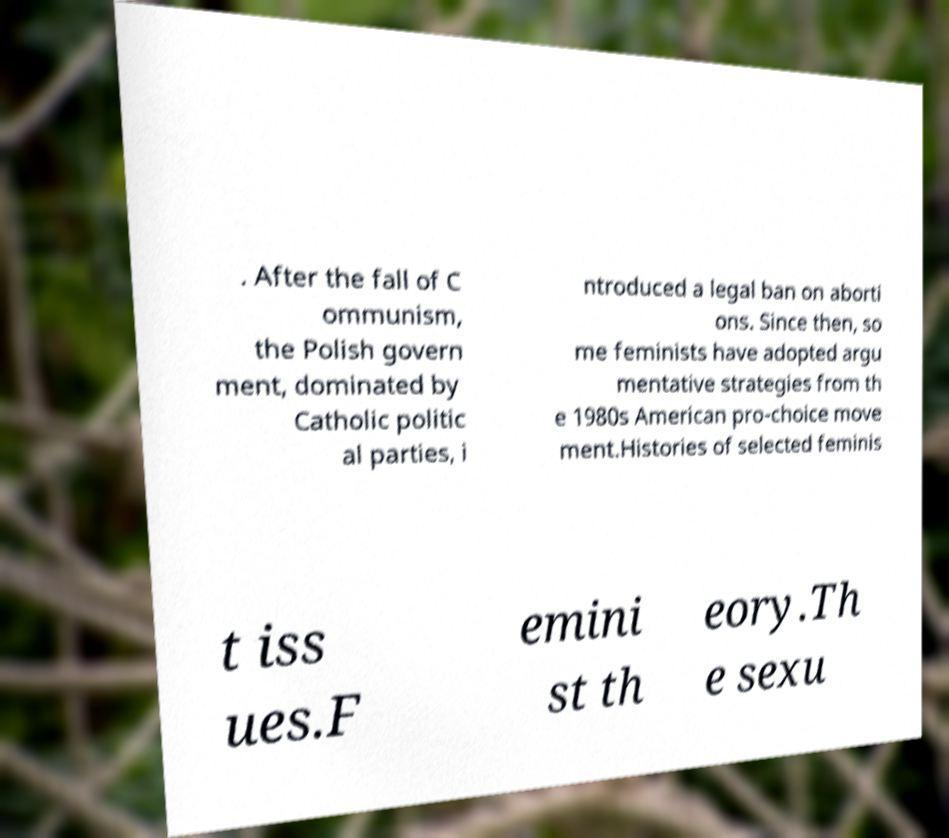Can you read and provide the text displayed in the image?This photo seems to have some interesting text. Can you extract and type it out for me? . After the fall of C ommunism, the Polish govern ment, dominated by Catholic politic al parties, i ntroduced a legal ban on aborti ons. Since then, so me feminists have adopted argu mentative strategies from th e 1980s American pro-choice move ment.Histories of selected feminis t iss ues.F emini st th eory.Th e sexu 